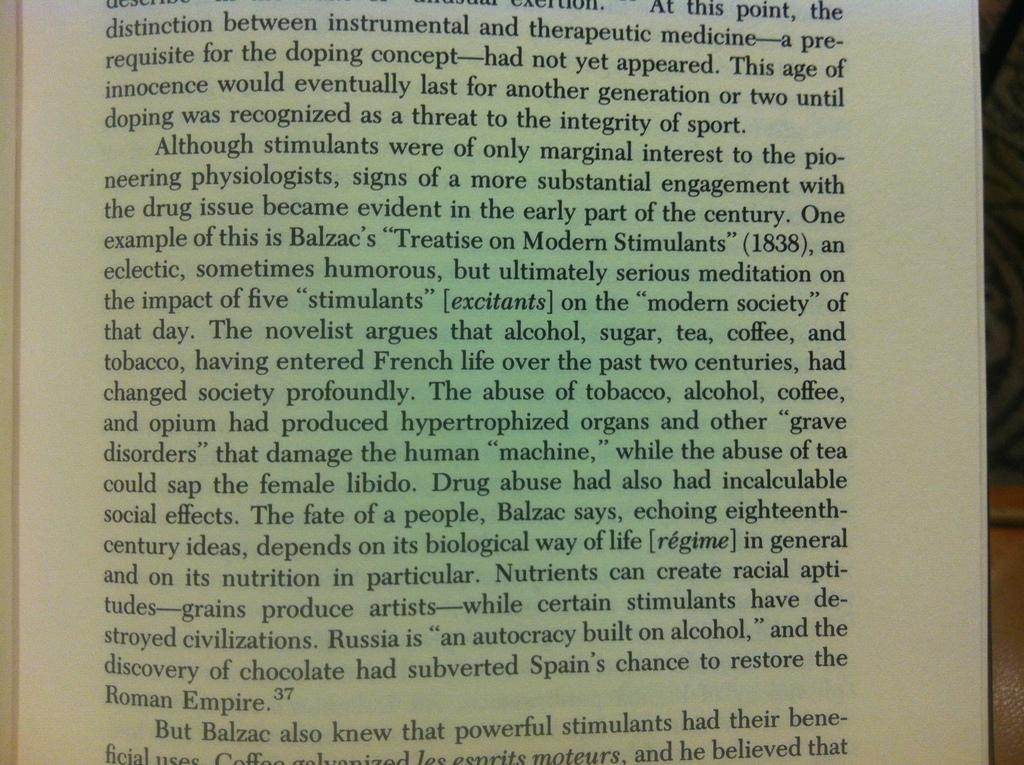What does the third line say?
Offer a terse response. Innocence would eventually last for another generation or two until. Who knew that powerful stimulant had beneficial use?
Offer a very short reply. Balzac. 